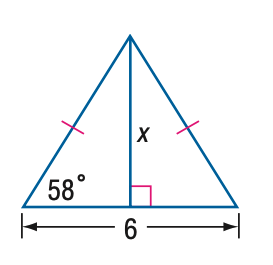Based on the image, directly select the correct answer for the following question: Find x. Round to the nearest tenth. Choices: A: 3.7, B: 4.8, C: 5.1, D: 6.0 The correct answer to find the value of 'x' in the given isosceles triangle is B: 4.8. To solve for 'x,' we can start by recognizing that the base angles in an isosceles triangle are equal. Therefore, the other base angle is also 58 degrees. By understanding that the sum of angles in a triangle is 180 degrees, we can find the vertex angle to be 180 - 58 - 58 = 64 degrees. With this, we can apply the Law of Sines or trigonometric ratios (for example, the tangent of half the vertex angle) to find the length of the sides relative to the base. After calculating, we round the result to the nearest tenth, confirming the original selection of 4.8 as the correct length of 'x'. 